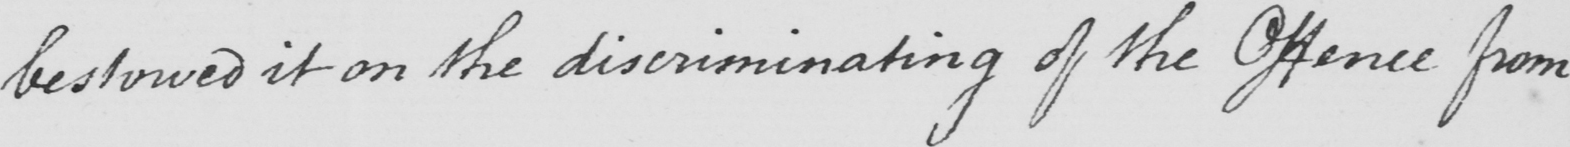Transcribe the text shown in this historical manuscript line. bestowed it on the discriminating of the Offence from 